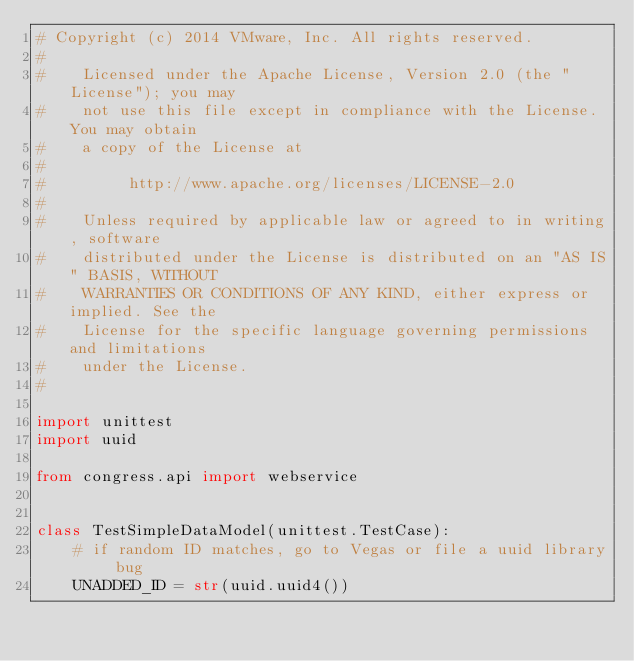Convert code to text. <code><loc_0><loc_0><loc_500><loc_500><_Python_># Copyright (c) 2014 VMware, Inc. All rights reserved.
#
#    Licensed under the Apache License, Version 2.0 (the "License"); you may
#    not use this file except in compliance with the License. You may obtain
#    a copy of the License at
#
#         http://www.apache.org/licenses/LICENSE-2.0
#
#    Unless required by applicable law or agreed to in writing, software
#    distributed under the License is distributed on an "AS IS" BASIS, WITHOUT
#    WARRANTIES OR CONDITIONS OF ANY KIND, either express or implied. See the
#    License for the specific language governing permissions and limitations
#    under the License.
#

import unittest
import uuid

from congress.api import webservice


class TestSimpleDataModel(unittest.TestCase):
    # if random ID matches, go to Vegas or file a uuid library bug
    UNADDED_ID = str(uuid.uuid4())</code> 